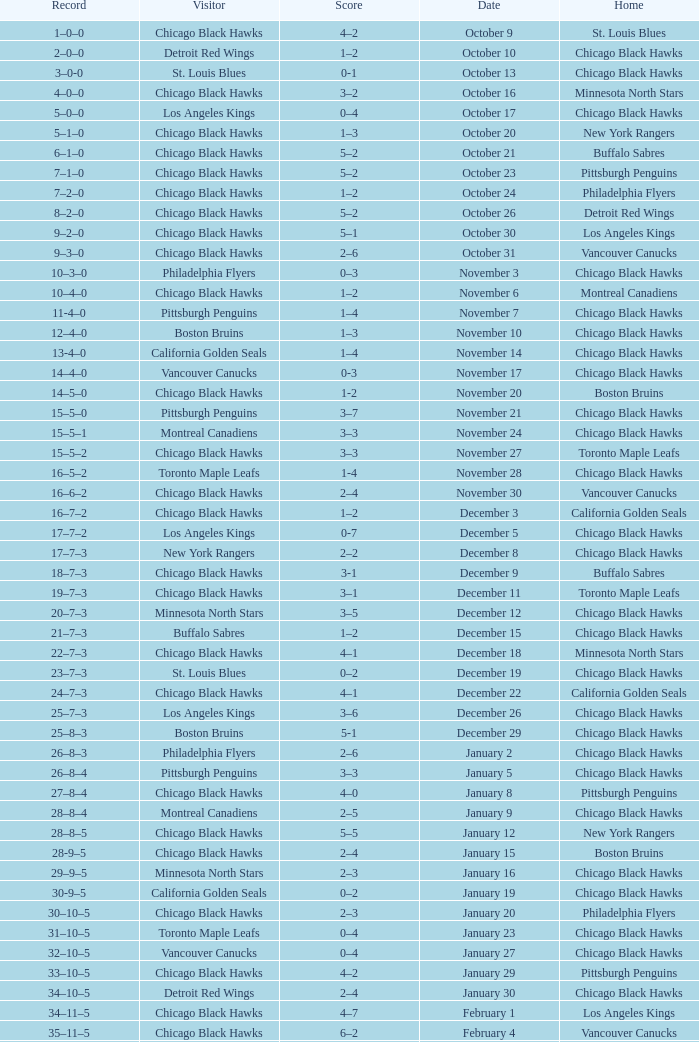What is the Record of the February 26 date? 39–16–7. 